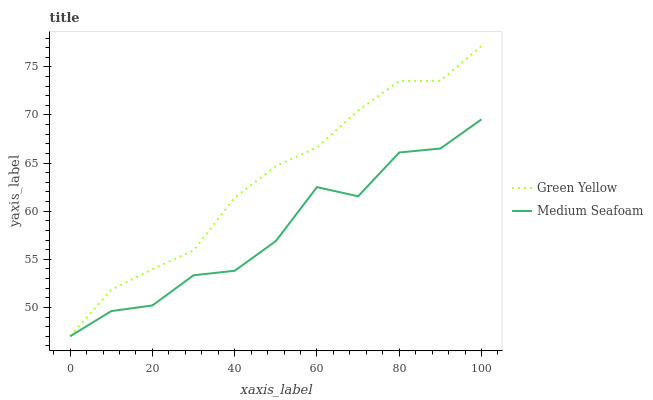Does Medium Seafoam have the minimum area under the curve?
Answer yes or no. Yes. Does Green Yellow have the maximum area under the curve?
Answer yes or no. Yes. Does Medium Seafoam have the maximum area under the curve?
Answer yes or no. No. Is Green Yellow the smoothest?
Answer yes or no. Yes. Is Medium Seafoam the roughest?
Answer yes or no. Yes. Is Medium Seafoam the smoothest?
Answer yes or no. No. Does Green Yellow have the lowest value?
Answer yes or no. Yes. Does Green Yellow have the highest value?
Answer yes or no. Yes. Does Medium Seafoam have the highest value?
Answer yes or no. No. Does Medium Seafoam intersect Green Yellow?
Answer yes or no. Yes. Is Medium Seafoam less than Green Yellow?
Answer yes or no. No. Is Medium Seafoam greater than Green Yellow?
Answer yes or no. No. 